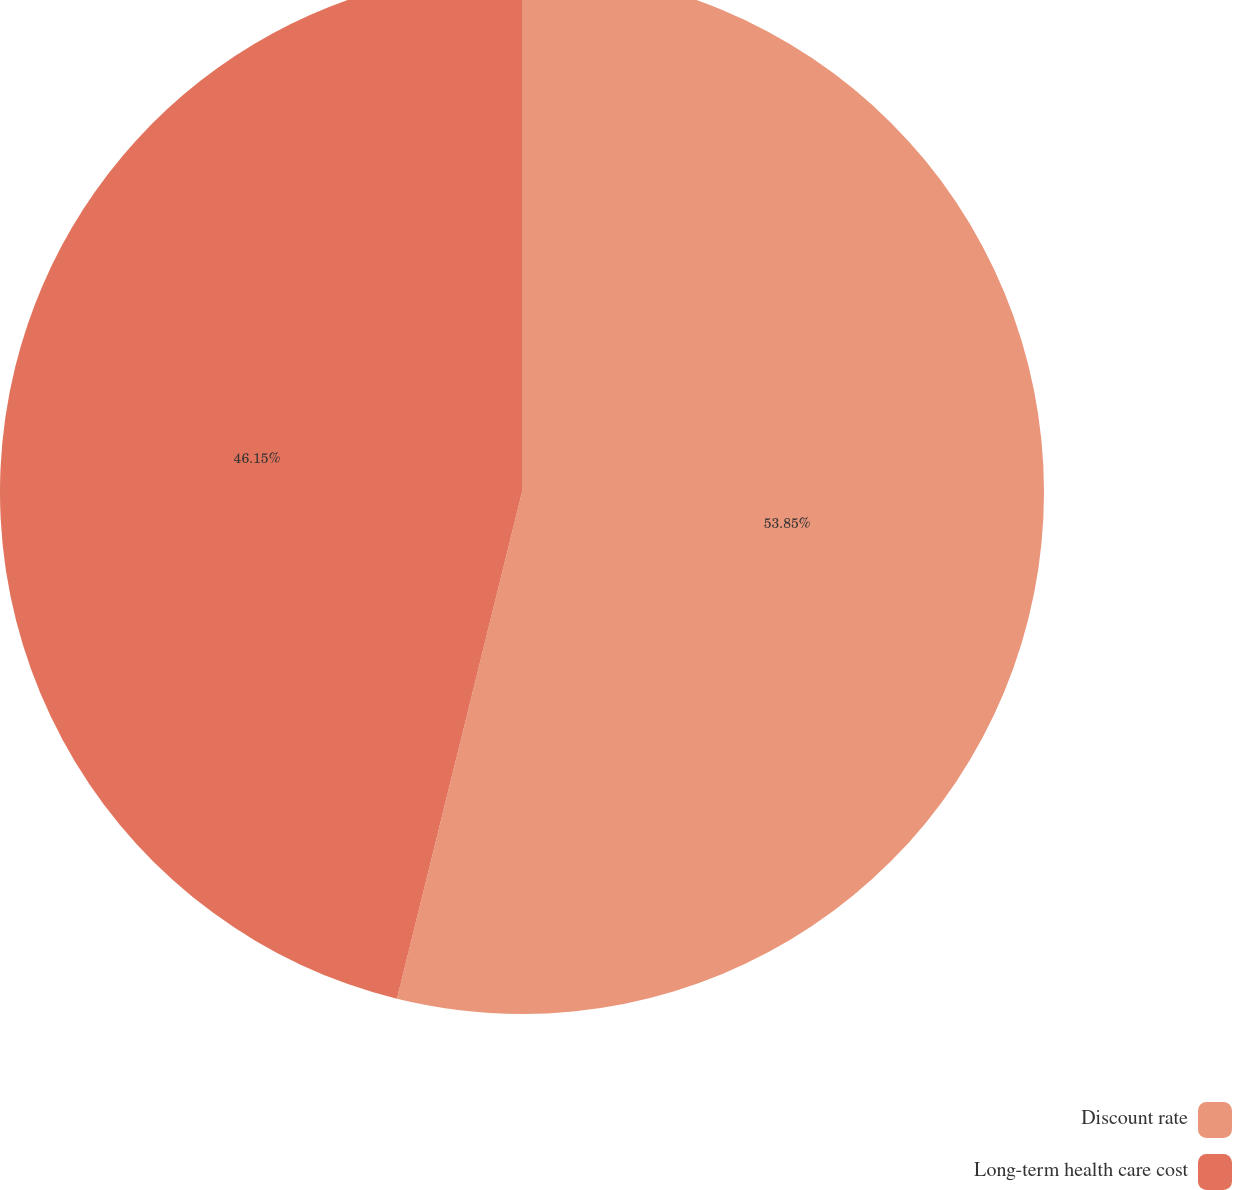Convert chart to OTSL. <chart><loc_0><loc_0><loc_500><loc_500><pie_chart><fcel>Discount rate<fcel>Long-term health care cost<nl><fcel>53.85%<fcel>46.15%<nl></chart> 